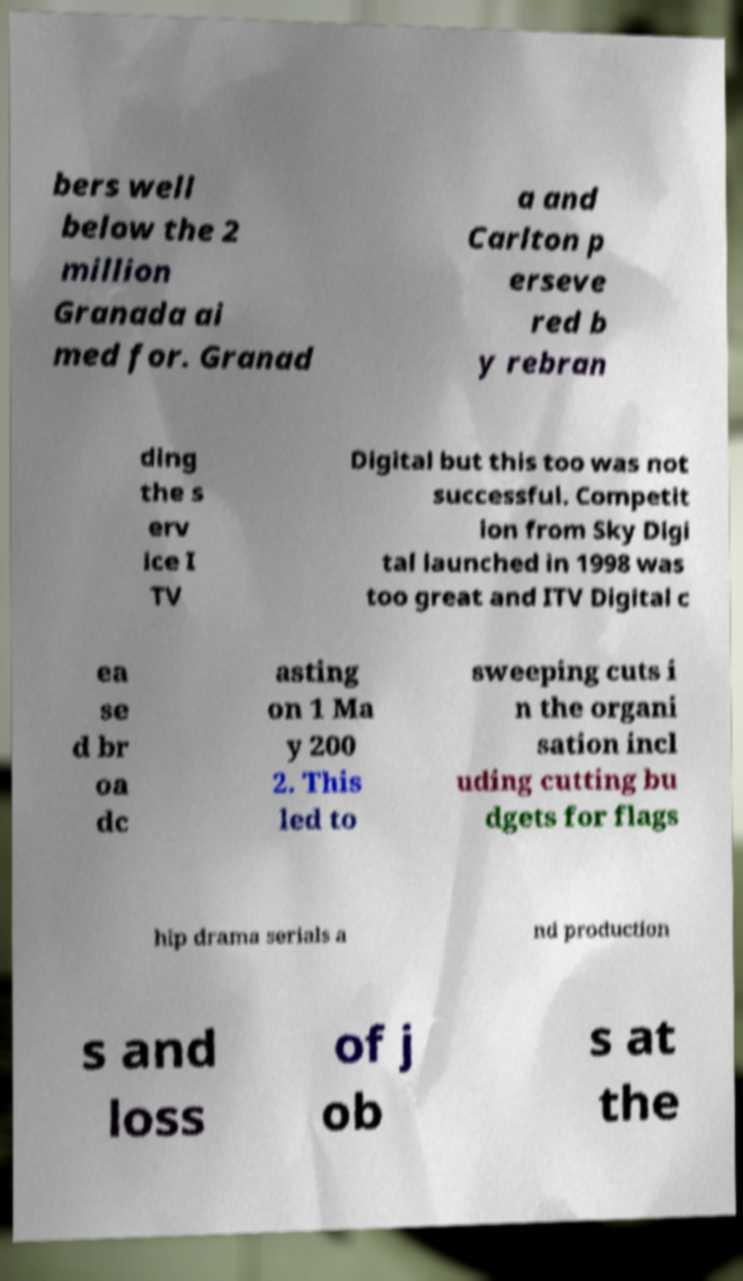I need the written content from this picture converted into text. Can you do that? bers well below the 2 million Granada ai med for. Granad a and Carlton p erseve red b y rebran ding the s erv ice I TV Digital but this too was not successful. Competit ion from Sky Digi tal launched in 1998 was too great and ITV Digital c ea se d br oa dc asting on 1 Ma y 200 2. This led to sweeping cuts i n the organi sation incl uding cutting bu dgets for flags hip drama serials a nd production s and loss of j ob s at the 